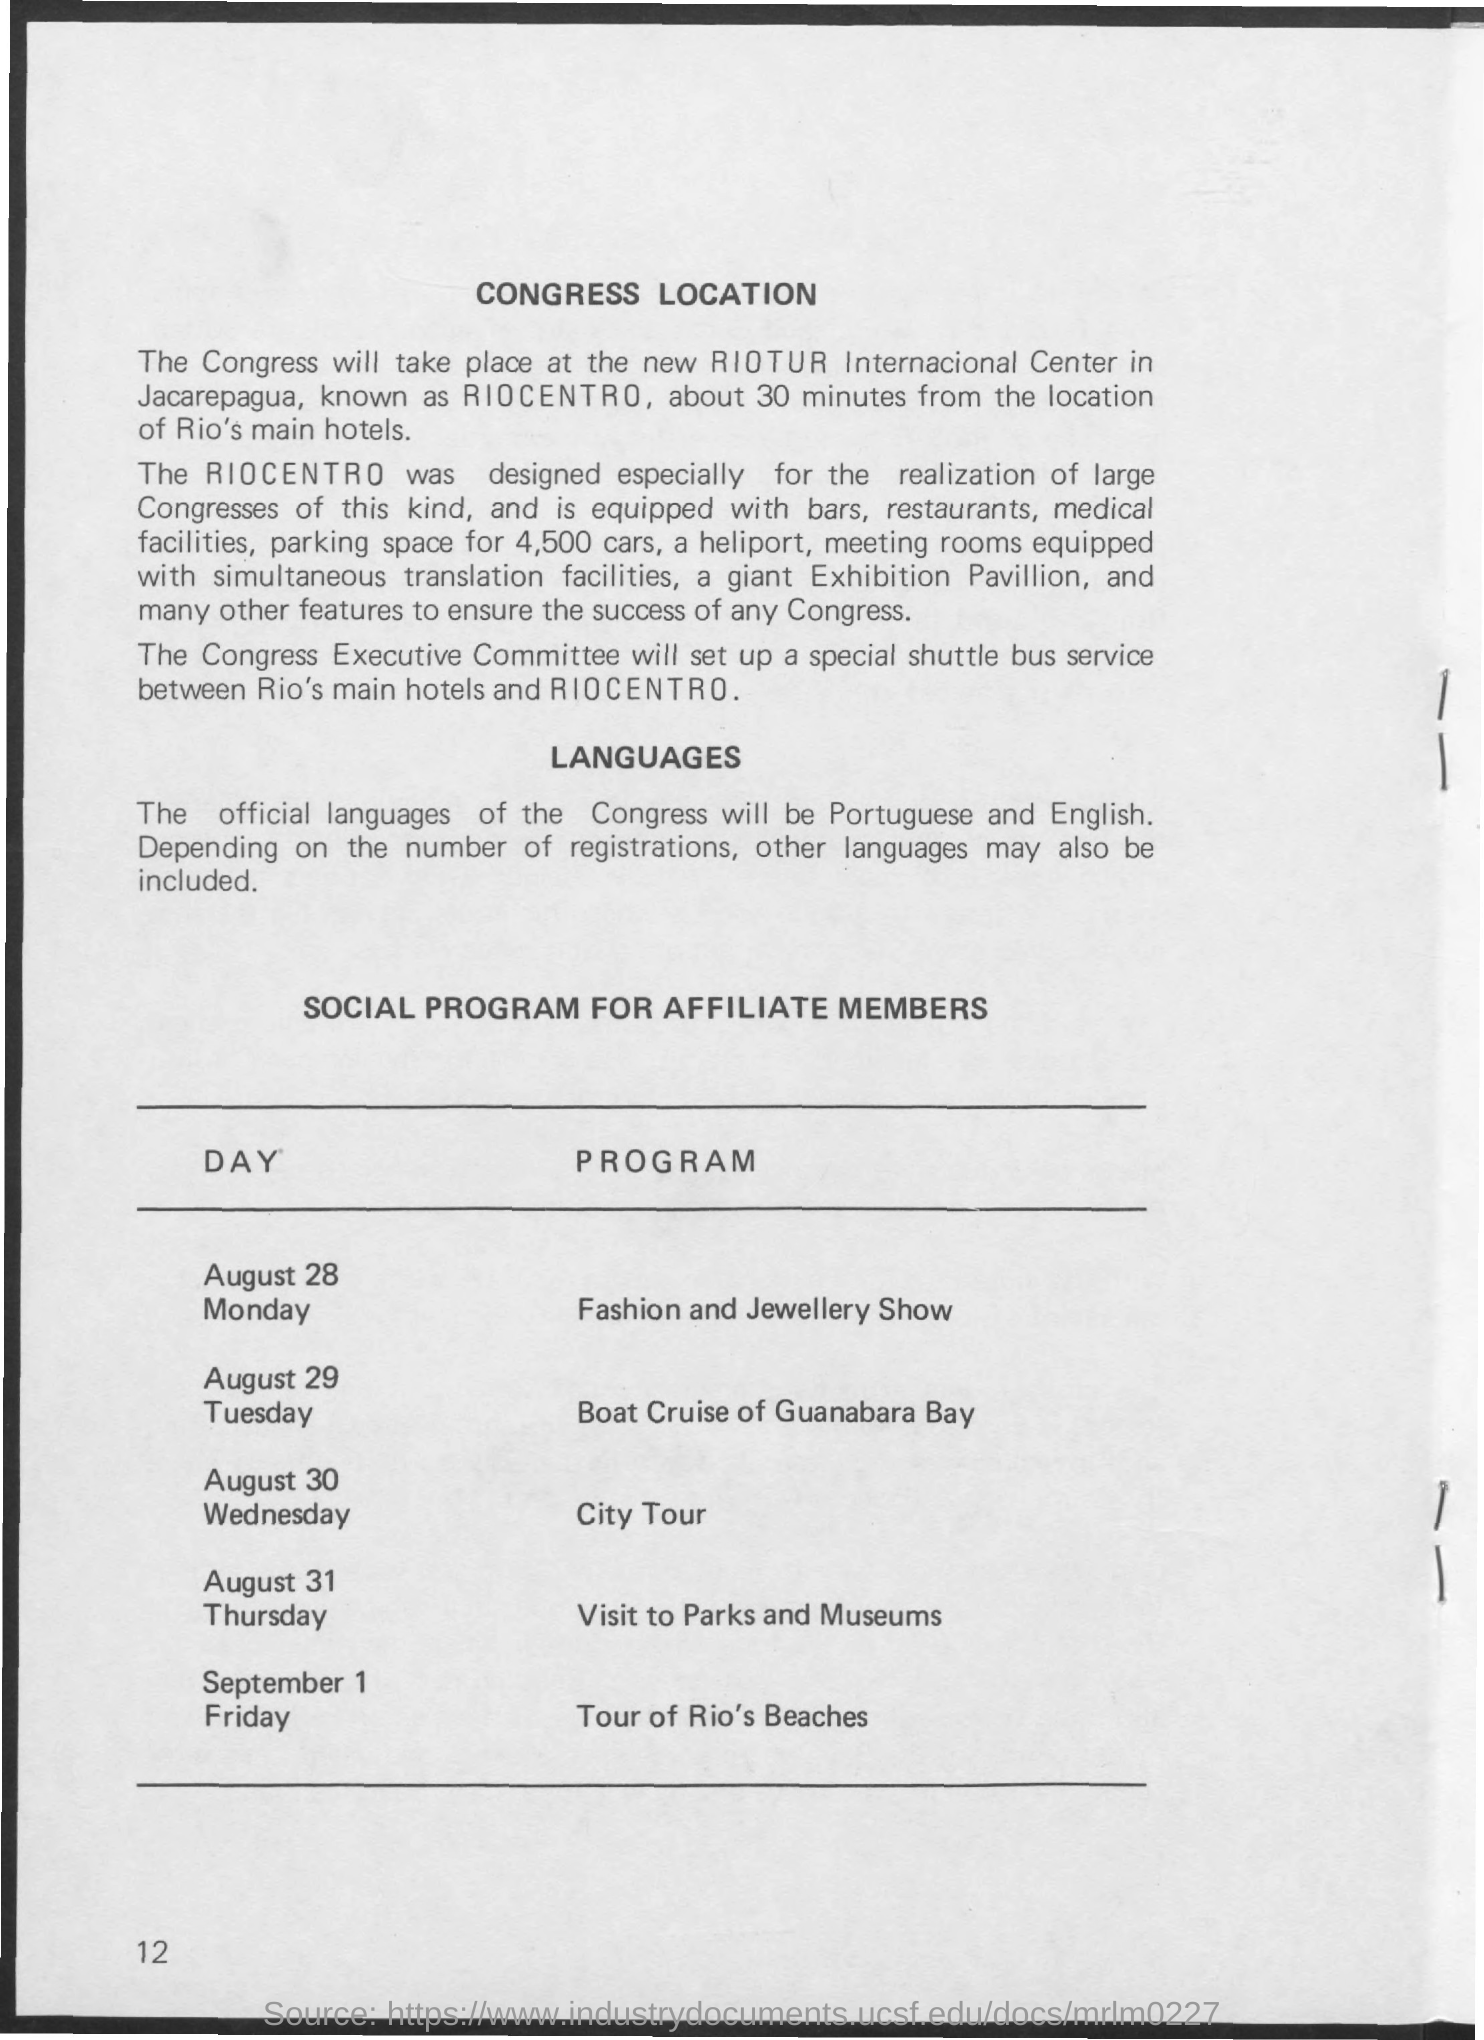Identify some key points in this picture. The social program is intended for Affiliate Members. On August 30, Wednesday, the program consists of a city tour. The location of the Congress will be at the new RIOTUR Internacional Center in Jacarepagua, also known as RIOCENTRO. The official languages of the Congress are Portuguese and English. The Fashion and Jewellery Show will take place on August 28, Monday. 